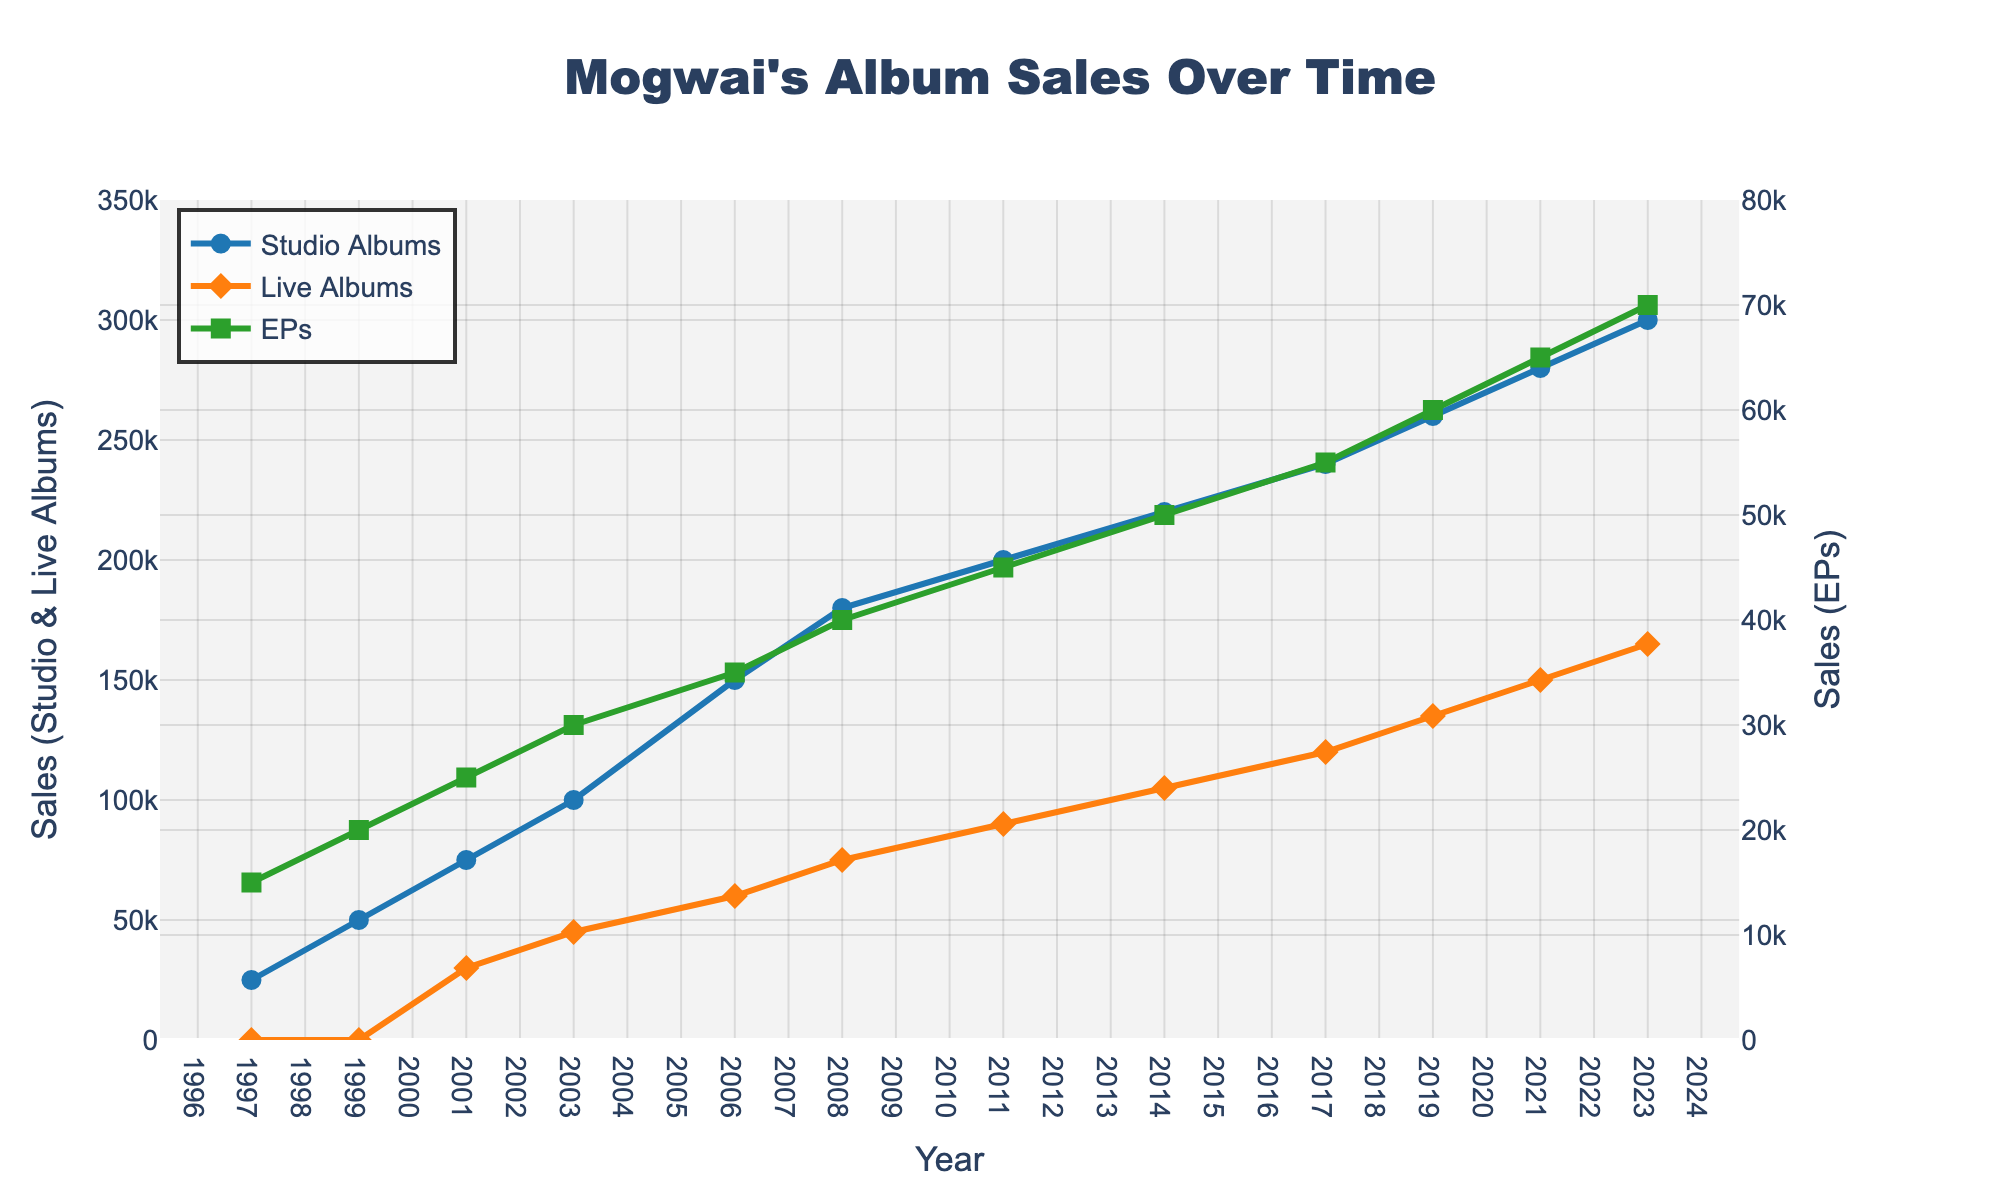what's the difference in sales between Studio Albums and Live Albums in 2023? The sales for Studio Albums in 2023 are 300,000 and for Live Albums, it is 165,000. The difference is 300,000 - 165,000 = 135,000
Answer: 135,000 Which album type has the highest sales in 2003? In 2003, Studio Albums have sales of 100,000, Live Albums have 45,000, and EPs have 30,000. The highest sales among these is for Studio Albums with 100,000
Answer: Studio Albums By how much did sales of EPs grow from 1997 to 2023? The sales of EPs in 1997 were 15,000 and in 2023 they are 70,000. The growth is 70,000 - 15,000 = 55,000
Answer: 55,000 What's the average sales of Studio Albums between 2006 and 2021? The sales of Studio Albums in these years are 150,000, 180,000, 200,000, 220,000, 240,000, 260,000, and 280,000. Summing these up gives us 1,530,000. The number of years is 7, so the average is 1,530,000 / 7 = 218,571
Answer: 218,571 In which year did Live Albums sales first exceed 100,000? Referring to the plot, Live Albums sales exceeded 100,000 for the first time in 2014 where the sales are 105,000
Answer: 2014 Is the trend of Studio Albums sales rising, falling, or staying constant from 1997 to 2023? From the figure, the sales of Studio Albums are consistently rising from 25,000 in 1997 to 300,000 in 2023. This indicates a rising trend
Answer: Rising Between which successive years was the largest growth in Studio Albums sales? Checking the increments between successive years: 1997-1999 (25,000), 1999-2001 (25,000), 2001-2003 (25,000), 2003-2006 (50,000), 2006-2008 (30,000), 2008-2011 (20,000), 2011-2014 (20,000), 2014-2017 (20,000), 2017-2019 (20,000), 2019-2021 (20,000), 2021-2023 (20,000). The largest growth was between 2003-2006 with 50,000 in sales growth
Answer: 2003-2006 What was the percentage increase in Live Albums sales from 2006 to 2023? Live Albums sales were 60,000 in 2006 and 165,000 in 2023. The increase is 165,000 - 60,000 = 105,000. The percentage increase is (105,000 / 60,000) * 100 ≈ 175%
Answer: 175% Which album type had the smallest increase in sales from 2011 to 2023? In 2011, the sales were: Studio Albums - 200,000, Live Albums - 90,000, EPs- 45,000. In 2023, they are: Studio Albums - 300,000, Live Albums - 165,000, EPs- 70,000. The differences are: Studio Albums (100,000), Live Albums (75,000), EPs (25,000). The smallest increase is for EPs with 25,000
Answer: EPs 